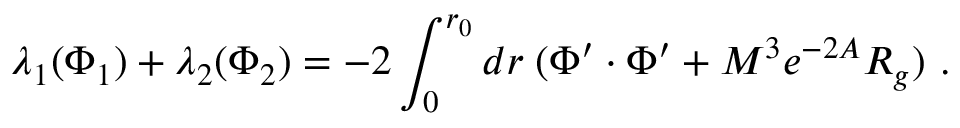Convert formula to latex. <formula><loc_0><loc_0><loc_500><loc_500>\lambda _ { 1 } ( \Phi _ { 1 } ) + \lambda _ { 2 } ( \Phi _ { 2 } ) = - 2 \int _ { 0 } ^ { r _ { 0 } } d r \, ( \Phi ^ { \prime } \cdot \Phi ^ { \prime } + M ^ { 3 } e ^ { - 2 A } R _ { g } ) .</formula> 